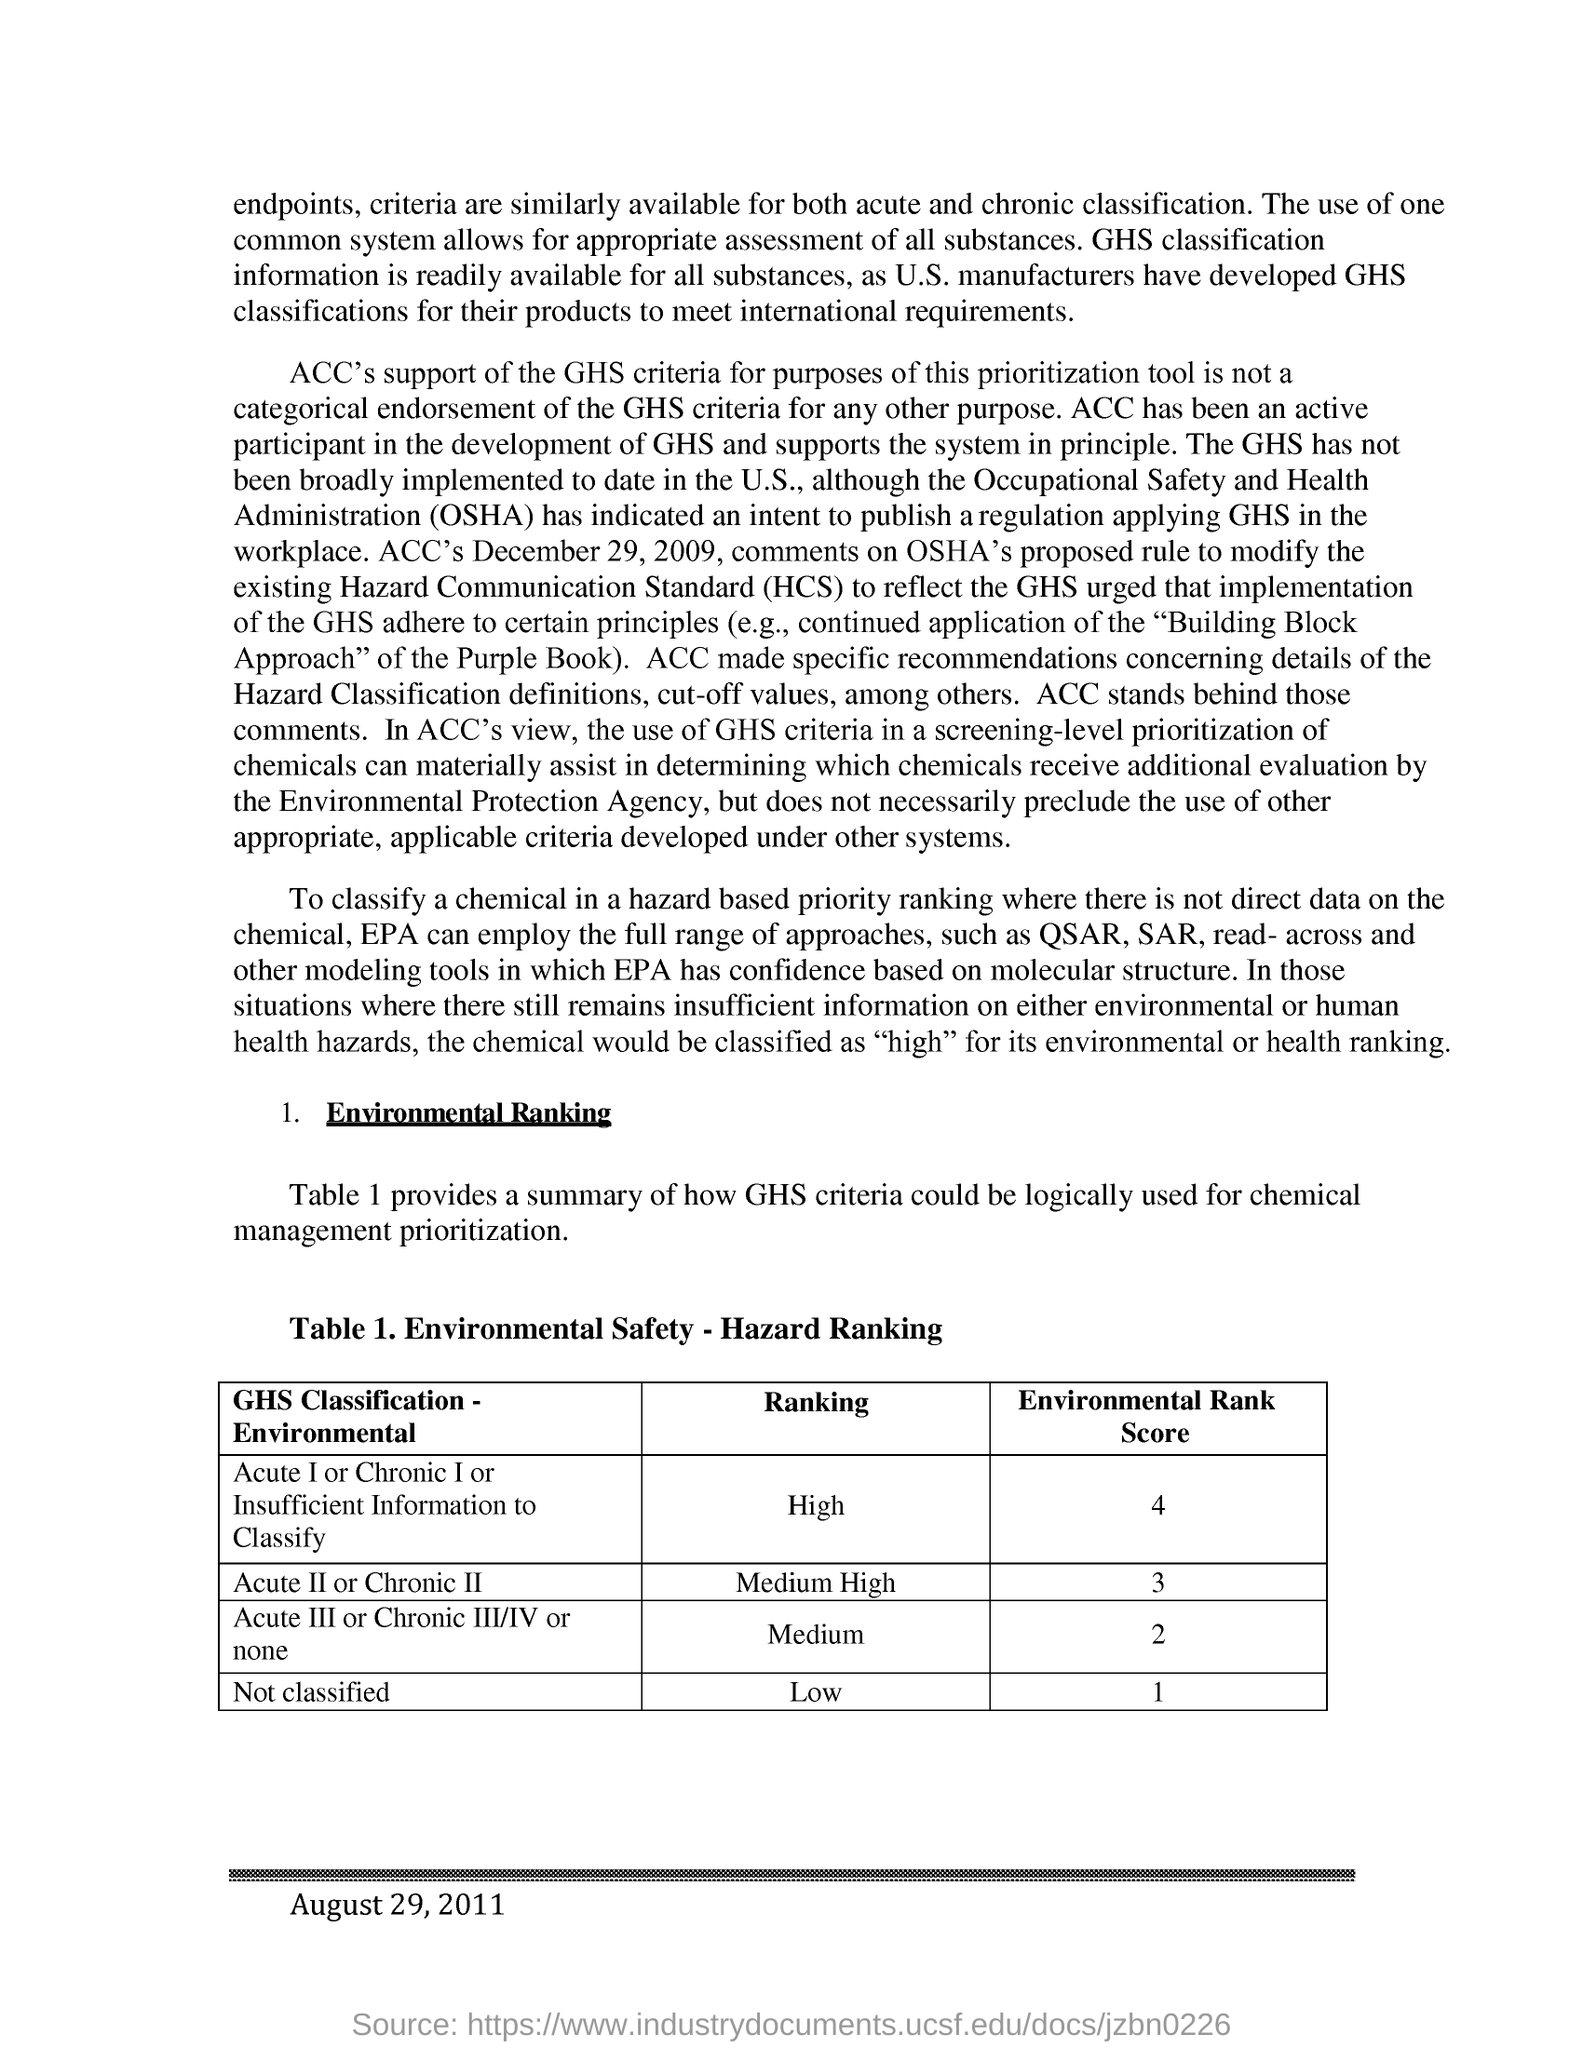Identify some key points in this picture. The classification of Acute II or Chronic II is considered to be of medium-high severity according to the GHS (Globally Harmonized System of Classification and Labeling of Chemicals). The full form of HCS is Hazard Communication Standard. The environmental risk score for Acute II or Chronic II, as classified by the Globally Harmonized System (GHS) classification, is 3. The Occupational Safety and Health Administration, commonly referred to as OSHA, is an agency of the United States Department of Labor responsible for ensuring safe and healthy working conditions for employees. The title of Table 1 is "Environmental Safety - Hazard Ranking. 